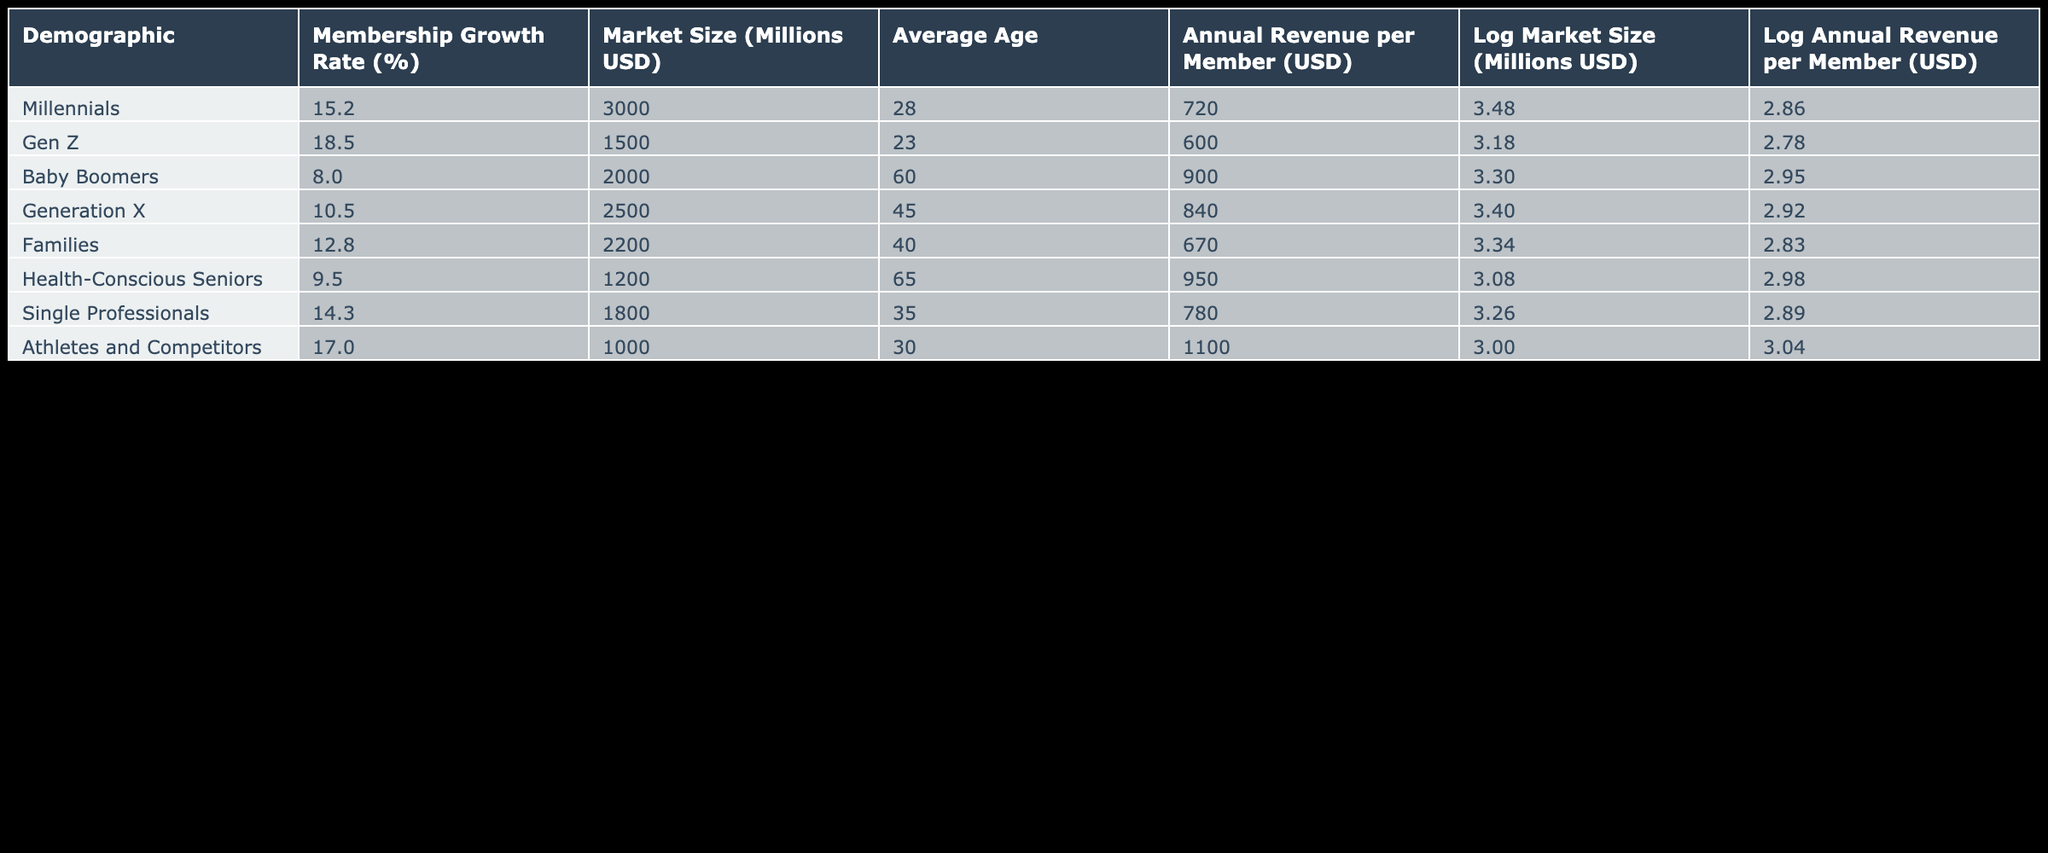What is the membership growth rate for Gen Z? The table shows that the membership growth rate for Gen Z is listed directly under the "Membership Growth Rate (%)" column. It is 18.5%.
Answer: 18.5% Which demographic has the highest annual revenue per member? By looking at the "Annual Revenue per Member (USD)" column, we can find that Athletes and Competitors have the highest annual revenue per member, which is 1100.
Answer: 1100 What is the average membership growth rate for Baby Boomers and Generation X combined? To find the average, we take the membership growth rates for Baby Boomers (8.0) and Generation X (10.5), add them together (8.0 + 10.5 = 18.5), and then divide by 2. The average is 18.5 / 2 = 9.25.
Answer: 9.25 Do Health-Conscious Seniors have a higher membership growth rate than Families? The membership growth rate for Health-Conscious Seniors is 9.5%, and for Families, it is 12.8%. Since 9.5% is less than 12.8%, the answer is no.
Answer: No Which demographic group has the highest market size? In the "Market Size (Millions USD)" column, we see that Millennials have the highest market size, recorded at 3000 million USD.
Answer: 3000 What is the difference in annual revenue per member between Baby Boomers and Single Professionals? The annual revenue per member for Baby Boomers is 900, and for Single Professionals, it is 780. To find the difference, we subtract 780 from 900: 900 - 780 = 120.
Answer: 120 Is the average age of Millennials lower than that of Generation X? The average age for Millennials is 28, while for Generation X, it is 45. Since 28 is lower than 45, the answer is yes.
Answer: Yes What is the market size for all demographics combined? To find the market size for all demographics, we will add all the market sizes: 3000 + 1500 + 2000 + 2500 + 2200 + 1200 + 1800 + 1000 = 15700 million USD.
Answer: 15700 